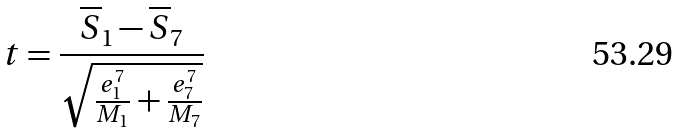Convert formula to latex. <formula><loc_0><loc_0><loc_500><loc_500>t = \frac { \overline { S } _ { 1 } - \overline { S } _ { 7 } } { \sqrt { \frac { e _ { 1 } ^ { 7 } } { M _ { 1 } } + \frac { e _ { 7 } ^ { 7 } } { M _ { 7 } } } }</formula> 